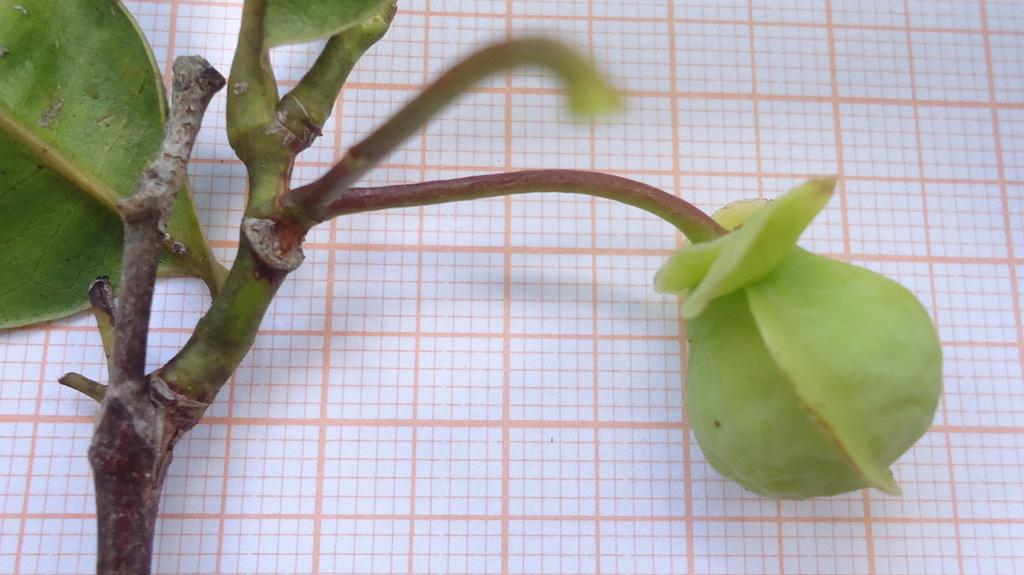What type of plant is visible in the image? There is a small plant in the image. Where is the plant located in the image? The plant is on the left side of the image. What is the growth stage of the plant? There is a bud on the plant, indicating it is in the early stages of growth. On which side of the plant is the bud located? The bud is on the right side of the plant. How many passengers are visible in the image? There are no passengers present in the image; it features a small plant with a bud. What type of yoke is used to support the plant in the image? There is no yoke present in the image; the plant is likely in a pot or on the ground. 